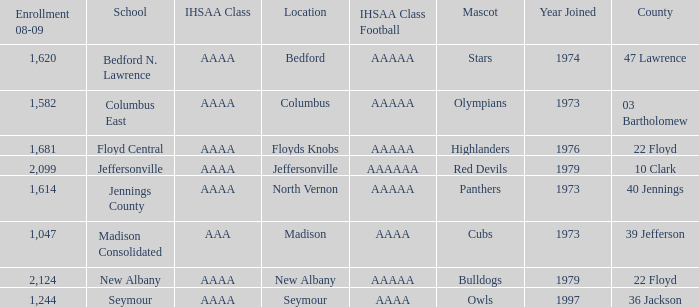Parse the table in full. {'header': ['Enrollment 08-09', 'School', 'IHSAA Class', 'Location', 'IHSAA Class Football', 'Mascot', 'Year Joined', 'County'], 'rows': [['1,620', 'Bedford N. Lawrence', 'AAAA', 'Bedford', 'AAAAA', 'Stars', '1974', '47 Lawrence'], ['1,582', 'Columbus East', 'AAAA', 'Columbus', 'AAAAA', 'Olympians', '1973', '03 Bartholomew'], ['1,681', 'Floyd Central', 'AAAA', 'Floyds Knobs', 'AAAAA', 'Highlanders', '1976', '22 Floyd'], ['2,099', 'Jeffersonville', 'AAAA', 'Jeffersonville', 'AAAAAA', 'Red Devils', '1979', '10 Clark'], ['1,614', 'Jennings County', 'AAAA', 'North Vernon', 'AAAAA', 'Panthers', '1973', '40 Jennings'], ['1,047', 'Madison Consolidated', 'AAA', 'Madison', 'AAAA', 'Cubs', '1973', '39 Jefferson'], ['2,124', 'New Albany', 'AAAA', 'New Albany', 'AAAAA', 'Bulldogs', '1979', '22 Floyd'], ['1,244', 'Seymour', 'AAAA', 'Seymour', 'AAAA', 'Owls', '1997', '36 Jackson']]} What's the IHSAA Class when the school is Seymour? AAAA. 